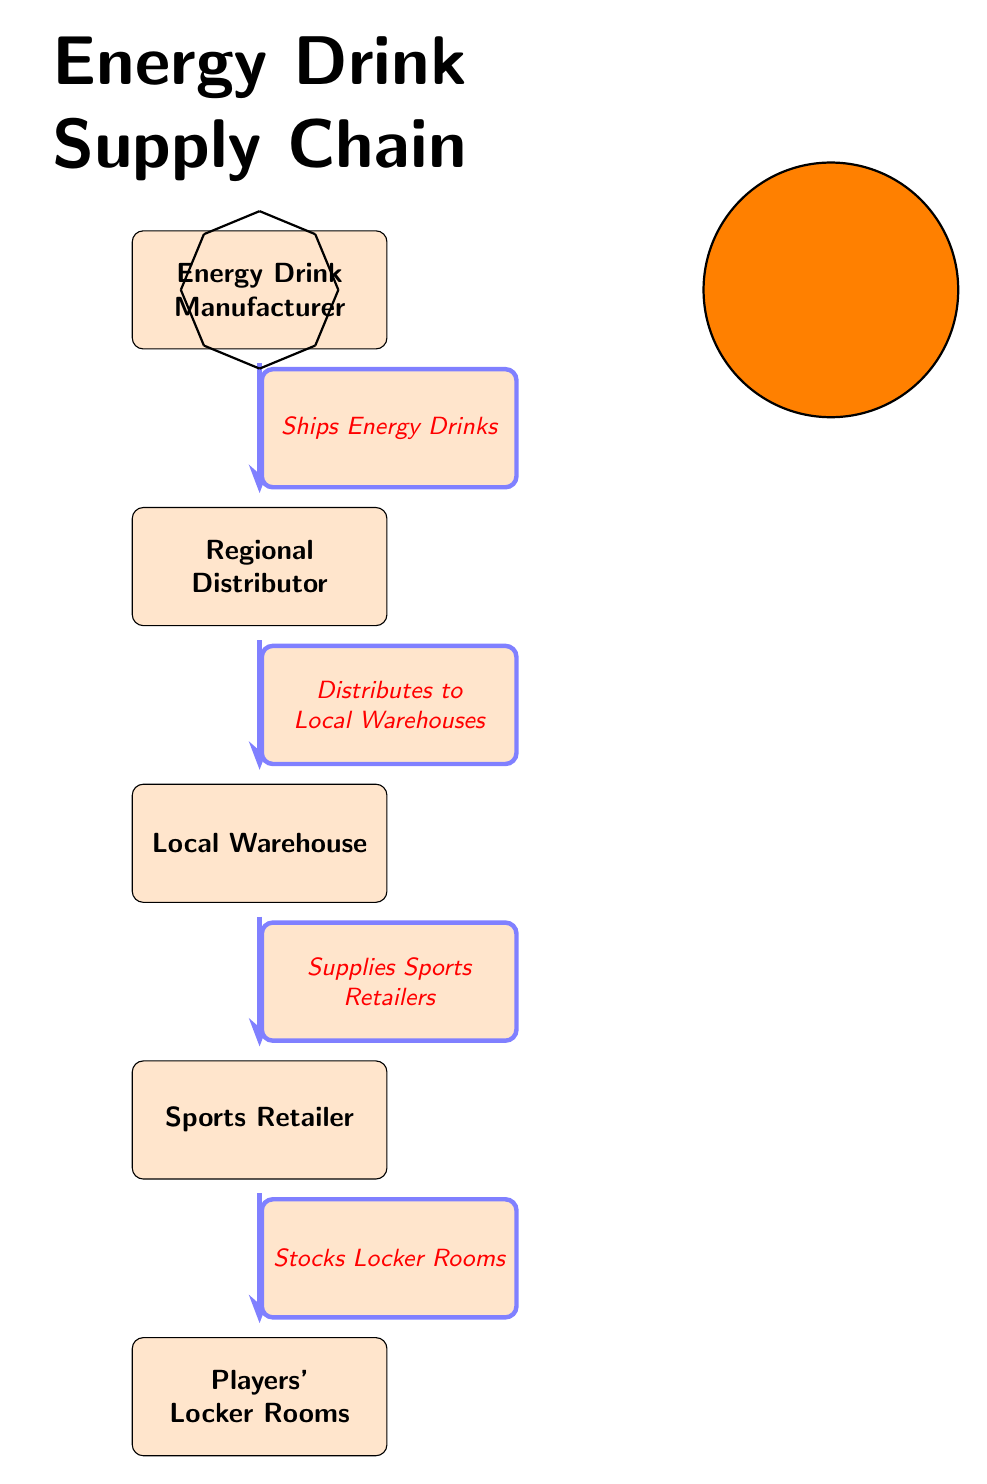What is the first step in the energy drink supply chain? The diagram indicates that the first step in the supply chain is from the Energy Drink Manufacturer to the Regional Distributor, signifying that the manufacturer ships energy drinks.
Answer: Ships Energy Drinks How many nodes are present in the diagram? The diagram displays five distinct nodes, which include the Energy Drink Manufacturer, Regional Distributor, Local Warehouse, Sports Retailer, and Players' Locker Rooms.
Answer: 5 What does the Regional Distributor do in the supply chain? The Regional Distributor's role is to distribute energy drinks to Local Warehouses as indicated in the diagram. This action is vital in the supply chain process.
Answer: Distributes to Local Warehouses Which node receives supplies from the Local Warehouse? The diagram shows that the Sports Retailer is the node that receives supplies from the Local Warehouse, according to the flow of the supply chain.
Answer: Sports Retailer What is the final destination of the energy drinks in this supply chain? Based on the flow of the diagram, the final destination of the energy drinks is the Players' Locker Rooms, where the energy drinks are stocked for the players.
Answer: Players' Locker Rooms What action takes place after the Sports Retailer in the supply chain? After the Sports Retailer, the action that takes place is stocking the Players' Locker Rooms with energy drinks, which signifies the final logistical step in the supply chain.
Answer: Stocks Locker Rooms How is the energy drink transported from the manufacturer to the distributor? The diagram illustrates that the energy drinks are shipped from the Energy Drink Manufacturer to the Regional Distributor, indicating a transport process in the supply chain.
Answer: Ships Energy Drinks Which element in the supply chain is responsible for the last supply before drinks reach players? The Sports Retailer is responsible for the last supply of energy drinks before they reach the Players' Locker Rooms, highlighting its crucial role in the supply chain.
Answer: Sports Retailer 